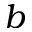Convert formula to latex. <formula><loc_0><loc_0><loc_500><loc_500>b</formula> 